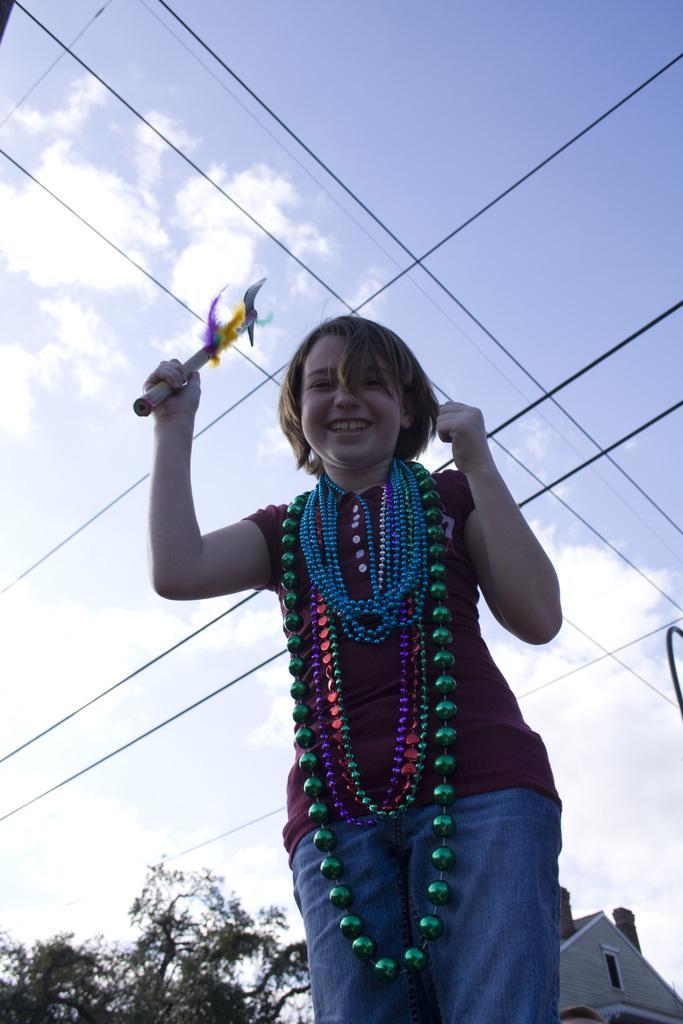Could you give a brief overview of what you see in this image? In this image we can see a person standing and holding a hand fan. In the background there are wires, tree, building and sky. 